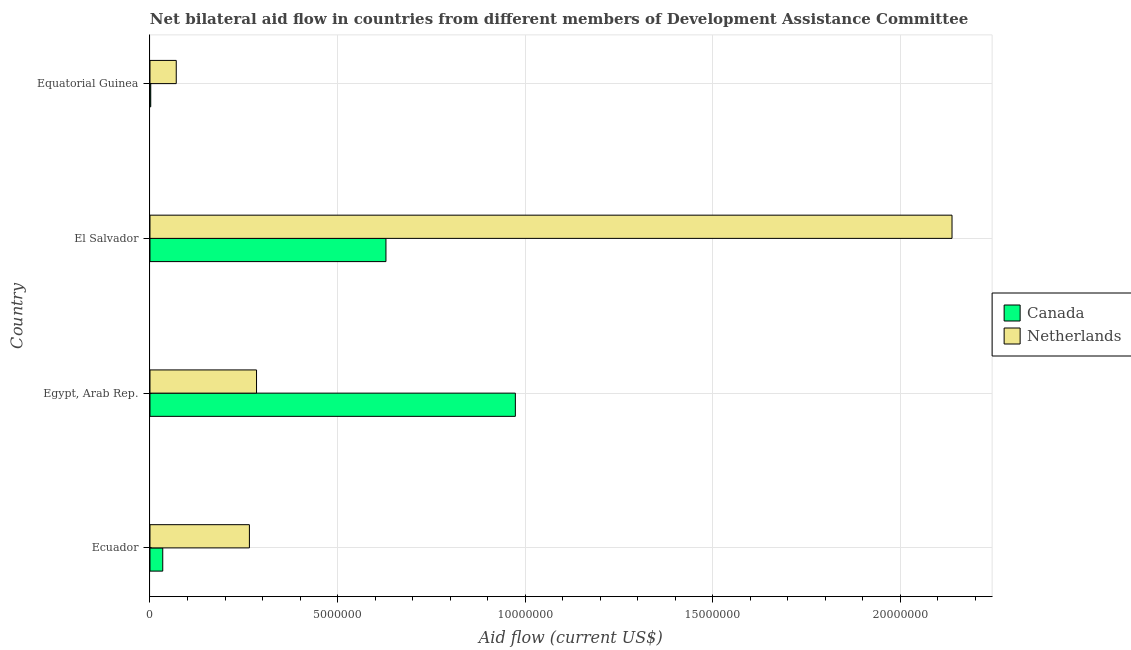How many groups of bars are there?
Your response must be concise. 4. How many bars are there on the 4th tick from the bottom?
Provide a short and direct response. 2. What is the label of the 1st group of bars from the top?
Give a very brief answer. Equatorial Guinea. What is the amount of aid given by netherlands in El Salvador?
Your answer should be compact. 2.14e+07. Across all countries, what is the maximum amount of aid given by canada?
Your response must be concise. 9.74e+06. Across all countries, what is the minimum amount of aid given by netherlands?
Ensure brevity in your answer.  7.00e+05. In which country was the amount of aid given by netherlands maximum?
Ensure brevity in your answer.  El Salvador. In which country was the amount of aid given by canada minimum?
Offer a very short reply. Equatorial Guinea. What is the total amount of aid given by canada in the graph?
Offer a terse response. 1.64e+07. What is the difference between the amount of aid given by netherlands in Ecuador and that in Egypt, Arab Rep.?
Provide a succinct answer. -1.90e+05. What is the difference between the amount of aid given by canada in Egypt, Arab Rep. and the amount of aid given by netherlands in El Salvador?
Ensure brevity in your answer.  -1.16e+07. What is the average amount of aid given by netherlands per country?
Provide a short and direct response. 6.89e+06. What is the difference between the amount of aid given by canada and amount of aid given by netherlands in Equatorial Guinea?
Keep it short and to the point. -6.80e+05. What is the ratio of the amount of aid given by netherlands in El Salvador to that in Equatorial Guinea?
Provide a succinct answer. 30.54. Is the difference between the amount of aid given by canada in Egypt, Arab Rep. and El Salvador greater than the difference between the amount of aid given by netherlands in Egypt, Arab Rep. and El Salvador?
Your response must be concise. Yes. What is the difference between the highest and the second highest amount of aid given by canada?
Offer a very short reply. 3.45e+06. What is the difference between the highest and the lowest amount of aid given by netherlands?
Provide a succinct answer. 2.07e+07. What does the 2nd bar from the top in El Salvador represents?
Ensure brevity in your answer.  Canada. What does the 1st bar from the bottom in El Salvador represents?
Your answer should be compact. Canada. How many bars are there?
Give a very brief answer. 8. Are all the bars in the graph horizontal?
Give a very brief answer. Yes. How many countries are there in the graph?
Provide a succinct answer. 4. What is the difference between two consecutive major ticks on the X-axis?
Your response must be concise. 5.00e+06. Does the graph contain grids?
Provide a short and direct response. Yes. Where does the legend appear in the graph?
Offer a very short reply. Center right. How are the legend labels stacked?
Provide a succinct answer. Vertical. What is the title of the graph?
Ensure brevity in your answer.  Net bilateral aid flow in countries from different members of Development Assistance Committee. What is the label or title of the X-axis?
Offer a terse response. Aid flow (current US$). What is the label or title of the Y-axis?
Provide a succinct answer. Country. What is the Aid flow (current US$) of Netherlands in Ecuador?
Give a very brief answer. 2.65e+06. What is the Aid flow (current US$) in Canada in Egypt, Arab Rep.?
Your answer should be very brief. 9.74e+06. What is the Aid flow (current US$) in Netherlands in Egypt, Arab Rep.?
Keep it short and to the point. 2.84e+06. What is the Aid flow (current US$) in Canada in El Salvador?
Your answer should be compact. 6.29e+06. What is the Aid flow (current US$) in Netherlands in El Salvador?
Your answer should be compact. 2.14e+07. What is the Aid flow (current US$) of Canada in Equatorial Guinea?
Offer a very short reply. 2.00e+04. Across all countries, what is the maximum Aid flow (current US$) of Canada?
Ensure brevity in your answer.  9.74e+06. Across all countries, what is the maximum Aid flow (current US$) in Netherlands?
Give a very brief answer. 2.14e+07. Across all countries, what is the minimum Aid flow (current US$) of Netherlands?
Provide a short and direct response. 7.00e+05. What is the total Aid flow (current US$) of Canada in the graph?
Provide a short and direct response. 1.64e+07. What is the total Aid flow (current US$) in Netherlands in the graph?
Offer a very short reply. 2.76e+07. What is the difference between the Aid flow (current US$) in Canada in Ecuador and that in Egypt, Arab Rep.?
Your response must be concise. -9.40e+06. What is the difference between the Aid flow (current US$) of Canada in Ecuador and that in El Salvador?
Provide a short and direct response. -5.95e+06. What is the difference between the Aid flow (current US$) in Netherlands in Ecuador and that in El Salvador?
Provide a succinct answer. -1.87e+07. What is the difference between the Aid flow (current US$) of Canada in Ecuador and that in Equatorial Guinea?
Give a very brief answer. 3.20e+05. What is the difference between the Aid flow (current US$) in Netherlands in Ecuador and that in Equatorial Guinea?
Make the answer very short. 1.95e+06. What is the difference between the Aid flow (current US$) of Canada in Egypt, Arab Rep. and that in El Salvador?
Offer a very short reply. 3.45e+06. What is the difference between the Aid flow (current US$) in Netherlands in Egypt, Arab Rep. and that in El Salvador?
Keep it short and to the point. -1.85e+07. What is the difference between the Aid flow (current US$) of Canada in Egypt, Arab Rep. and that in Equatorial Guinea?
Ensure brevity in your answer.  9.72e+06. What is the difference between the Aid flow (current US$) in Netherlands in Egypt, Arab Rep. and that in Equatorial Guinea?
Your answer should be very brief. 2.14e+06. What is the difference between the Aid flow (current US$) of Canada in El Salvador and that in Equatorial Guinea?
Provide a short and direct response. 6.27e+06. What is the difference between the Aid flow (current US$) of Netherlands in El Salvador and that in Equatorial Guinea?
Your answer should be compact. 2.07e+07. What is the difference between the Aid flow (current US$) in Canada in Ecuador and the Aid flow (current US$) in Netherlands in Egypt, Arab Rep.?
Offer a very short reply. -2.50e+06. What is the difference between the Aid flow (current US$) of Canada in Ecuador and the Aid flow (current US$) of Netherlands in El Salvador?
Ensure brevity in your answer.  -2.10e+07. What is the difference between the Aid flow (current US$) of Canada in Ecuador and the Aid flow (current US$) of Netherlands in Equatorial Guinea?
Ensure brevity in your answer.  -3.60e+05. What is the difference between the Aid flow (current US$) of Canada in Egypt, Arab Rep. and the Aid flow (current US$) of Netherlands in El Salvador?
Provide a succinct answer. -1.16e+07. What is the difference between the Aid flow (current US$) of Canada in Egypt, Arab Rep. and the Aid flow (current US$) of Netherlands in Equatorial Guinea?
Make the answer very short. 9.04e+06. What is the difference between the Aid flow (current US$) of Canada in El Salvador and the Aid flow (current US$) of Netherlands in Equatorial Guinea?
Your response must be concise. 5.59e+06. What is the average Aid flow (current US$) in Canada per country?
Offer a very short reply. 4.10e+06. What is the average Aid flow (current US$) of Netherlands per country?
Your answer should be compact. 6.89e+06. What is the difference between the Aid flow (current US$) in Canada and Aid flow (current US$) in Netherlands in Ecuador?
Make the answer very short. -2.31e+06. What is the difference between the Aid flow (current US$) in Canada and Aid flow (current US$) in Netherlands in Egypt, Arab Rep.?
Provide a succinct answer. 6.90e+06. What is the difference between the Aid flow (current US$) in Canada and Aid flow (current US$) in Netherlands in El Salvador?
Offer a terse response. -1.51e+07. What is the difference between the Aid flow (current US$) of Canada and Aid flow (current US$) of Netherlands in Equatorial Guinea?
Provide a short and direct response. -6.80e+05. What is the ratio of the Aid flow (current US$) of Canada in Ecuador to that in Egypt, Arab Rep.?
Make the answer very short. 0.03. What is the ratio of the Aid flow (current US$) in Netherlands in Ecuador to that in Egypt, Arab Rep.?
Make the answer very short. 0.93. What is the ratio of the Aid flow (current US$) of Canada in Ecuador to that in El Salvador?
Offer a very short reply. 0.05. What is the ratio of the Aid flow (current US$) of Netherlands in Ecuador to that in El Salvador?
Give a very brief answer. 0.12. What is the ratio of the Aid flow (current US$) in Netherlands in Ecuador to that in Equatorial Guinea?
Your answer should be compact. 3.79. What is the ratio of the Aid flow (current US$) of Canada in Egypt, Arab Rep. to that in El Salvador?
Make the answer very short. 1.55. What is the ratio of the Aid flow (current US$) in Netherlands in Egypt, Arab Rep. to that in El Salvador?
Your answer should be very brief. 0.13. What is the ratio of the Aid flow (current US$) of Canada in Egypt, Arab Rep. to that in Equatorial Guinea?
Offer a very short reply. 487. What is the ratio of the Aid flow (current US$) in Netherlands in Egypt, Arab Rep. to that in Equatorial Guinea?
Ensure brevity in your answer.  4.06. What is the ratio of the Aid flow (current US$) in Canada in El Salvador to that in Equatorial Guinea?
Provide a succinct answer. 314.5. What is the ratio of the Aid flow (current US$) of Netherlands in El Salvador to that in Equatorial Guinea?
Offer a terse response. 30.54. What is the difference between the highest and the second highest Aid flow (current US$) of Canada?
Your response must be concise. 3.45e+06. What is the difference between the highest and the second highest Aid flow (current US$) in Netherlands?
Offer a terse response. 1.85e+07. What is the difference between the highest and the lowest Aid flow (current US$) of Canada?
Your response must be concise. 9.72e+06. What is the difference between the highest and the lowest Aid flow (current US$) in Netherlands?
Your response must be concise. 2.07e+07. 